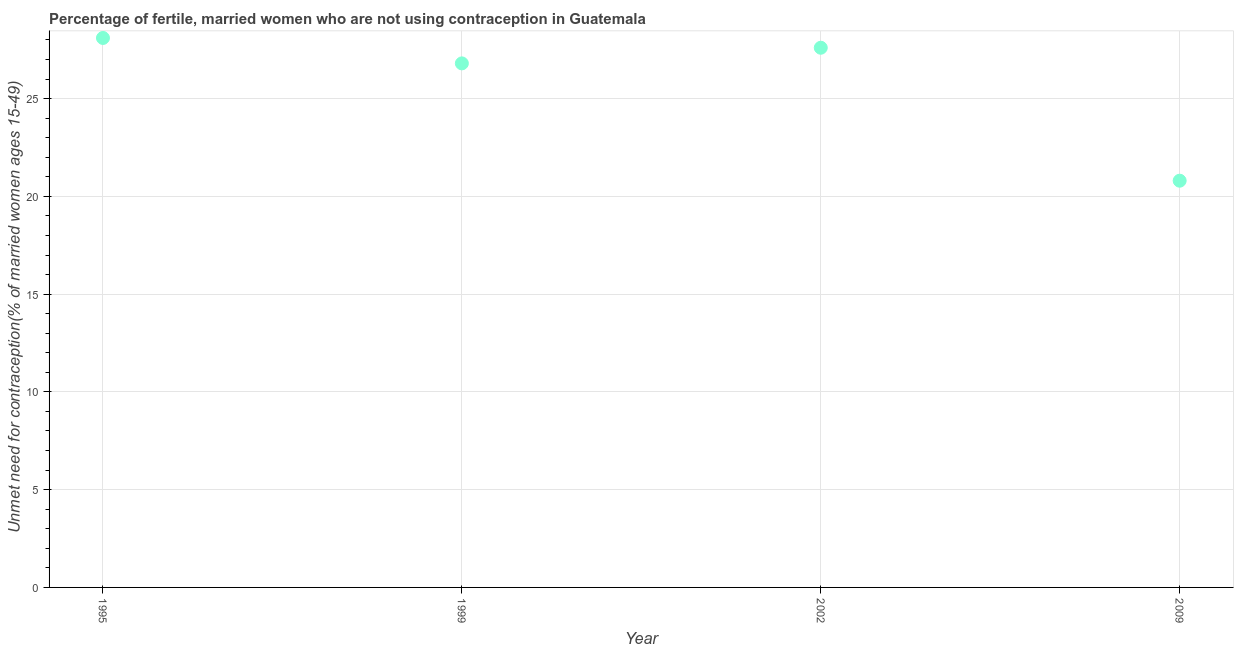What is the number of married women who are not using contraception in 2002?
Offer a very short reply. 27.6. Across all years, what is the maximum number of married women who are not using contraception?
Provide a short and direct response. 28.1. Across all years, what is the minimum number of married women who are not using contraception?
Your answer should be very brief. 20.8. In which year was the number of married women who are not using contraception minimum?
Your answer should be compact. 2009. What is the sum of the number of married women who are not using contraception?
Offer a very short reply. 103.3. What is the difference between the number of married women who are not using contraception in 1999 and 2002?
Ensure brevity in your answer.  -0.8. What is the average number of married women who are not using contraception per year?
Your response must be concise. 25.82. What is the median number of married women who are not using contraception?
Provide a short and direct response. 27.2. Do a majority of the years between 1999 and 2002 (inclusive) have number of married women who are not using contraception greater than 14 %?
Offer a terse response. Yes. What is the ratio of the number of married women who are not using contraception in 1995 to that in 2009?
Your response must be concise. 1.35. Is the number of married women who are not using contraception in 1995 less than that in 2009?
Ensure brevity in your answer.  No. Is the difference between the number of married women who are not using contraception in 1995 and 2009 greater than the difference between any two years?
Provide a short and direct response. Yes. What is the difference between the highest and the lowest number of married women who are not using contraception?
Provide a short and direct response. 7.3. In how many years, is the number of married women who are not using contraception greater than the average number of married women who are not using contraception taken over all years?
Keep it short and to the point. 3. Does the number of married women who are not using contraception monotonically increase over the years?
Your answer should be very brief. No. How many years are there in the graph?
Your response must be concise. 4. Does the graph contain any zero values?
Offer a terse response. No. What is the title of the graph?
Offer a very short reply. Percentage of fertile, married women who are not using contraception in Guatemala. What is the label or title of the X-axis?
Provide a succinct answer. Year. What is the label or title of the Y-axis?
Offer a very short reply.  Unmet need for contraception(% of married women ages 15-49). What is the  Unmet need for contraception(% of married women ages 15-49) in 1995?
Make the answer very short. 28.1. What is the  Unmet need for contraception(% of married women ages 15-49) in 1999?
Your response must be concise. 26.8. What is the  Unmet need for contraception(% of married women ages 15-49) in 2002?
Offer a terse response. 27.6. What is the  Unmet need for contraception(% of married women ages 15-49) in 2009?
Your answer should be compact. 20.8. What is the difference between the  Unmet need for contraception(% of married women ages 15-49) in 1995 and 2002?
Keep it short and to the point. 0.5. What is the difference between the  Unmet need for contraception(% of married women ages 15-49) in 1999 and 2002?
Make the answer very short. -0.8. What is the difference between the  Unmet need for contraception(% of married women ages 15-49) in 1999 and 2009?
Your answer should be very brief. 6. What is the difference between the  Unmet need for contraception(% of married women ages 15-49) in 2002 and 2009?
Your answer should be compact. 6.8. What is the ratio of the  Unmet need for contraception(% of married women ages 15-49) in 1995 to that in 1999?
Make the answer very short. 1.05. What is the ratio of the  Unmet need for contraception(% of married women ages 15-49) in 1995 to that in 2002?
Your answer should be very brief. 1.02. What is the ratio of the  Unmet need for contraception(% of married women ages 15-49) in 1995 to that in 2009?
Provide a succinct answer. 1.35. What is the ratio of the  Unmet need for contraception(% of married women ages 15-49) in 1999 to that in 2002?
Give a very brief answer. 0.97. What is the ratio of the  Unmet need for contraception(% of married women ages 15-49) in 1999 to that in 2009?
Offer a very short reply. 1.29. What is the ratio of the  Unmet need for contraception(% of married women ages 15-49) in 2002 to that in 2009?
Your answer should be very brief. 1.33. 